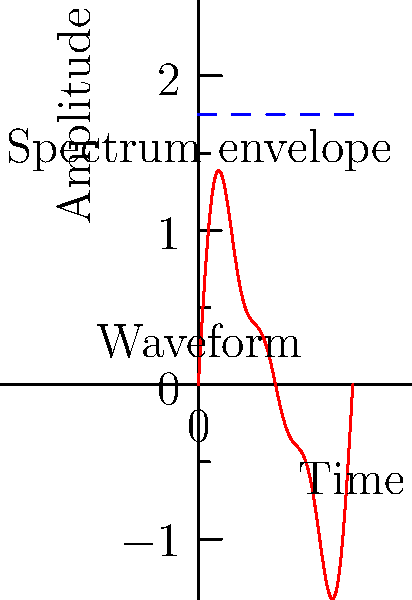In the context of a synthesizer used in electronic and goth-rock music, analyze the frequency spectrum of the waveform shown in red. If the fundamental frequency is 440 Hz (A4 note), what is the frequency of the highest significant harmonic component visible in the spectrum? To solve this problem, let's follow these steps:

1) The waveform (red) appears to be a complex periodic wave, which is typical for synthesizer sounds in electronic and goth-rock music.

2) The blue dashed line represents the spectrum envelope, showing the amplitudes of different frequency components.

3) We can see that there are three clear steps in the spectrum envelope, indicating three significant harmonic components.

4) In a harmonic series, the frequencies of harmonics are integer multiples of the fundamental frequency.

5) Given that the fundamental frequency is 440 Hz (A4 note), the harmonics would be:
   - 1st harmonic (fundamental): 440 Hz
   - 2nd harmonic: 880 Hz
   - 3rd harmonic: 1320 Hz

6) The highest significant harmonic visible in the spectrum is the 3rd harmonic.

7) Therefore, the frequency of the highest significant harmonic is:

   $f = 3 \times 440 \text{ Hz} = 1320 \text{ Hz}$
Answer: 1320 Hz 